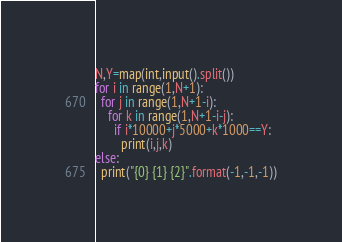Convert code to text. <code><loc_0><loc_0><loc_500><loc_500><_Python_>N,Y=map(int,input().split())
for i in range(1,N+1):
  for j in range(1,N+1-i):
    for k in range(1,N+1-i-j):
      if i*10000+j*5000+k*1000==Y:
        print(i,j,k)
else:
  print("{0} {1} {2}".format(-1,-1,-1))</code> 